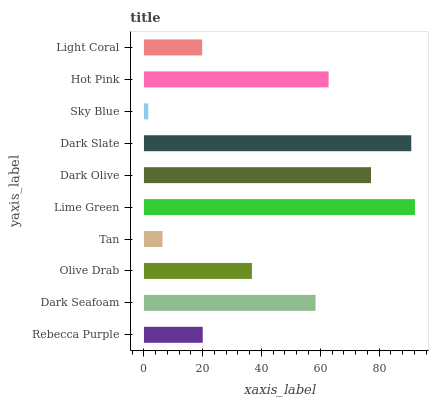Is Sky Blue the minimum?
Answer yes or no. Yes. Is Lime Green the maximum?
Answer yes or no. Yes. Is Dark Seafoam the minimum?
Answer yes or no. No. Is Dark Seafoam the maximum?
Answer yes or no. No. Is Dark Seafoam greater than Rebecca Purple?
Answer yes or no. Yes. Is Rebecca Purple less than Dark Seafoam?
Answer yes or no. Yes. Is Rebecca Purple greater than Dark Seafoam?
Answer yes or no. No. Is Dark Seafoam less than Rebecca Purple?
Answer yes or no. No. Is Dark Seafoam the high median?
Answer yes or no. Yes. Is Olive Drab the low median?
Answer yes or no. Yes. Is Dark Slate the high median?
Answer yes or no. No. Is Tan the low median?
Answer yes or no. No. 